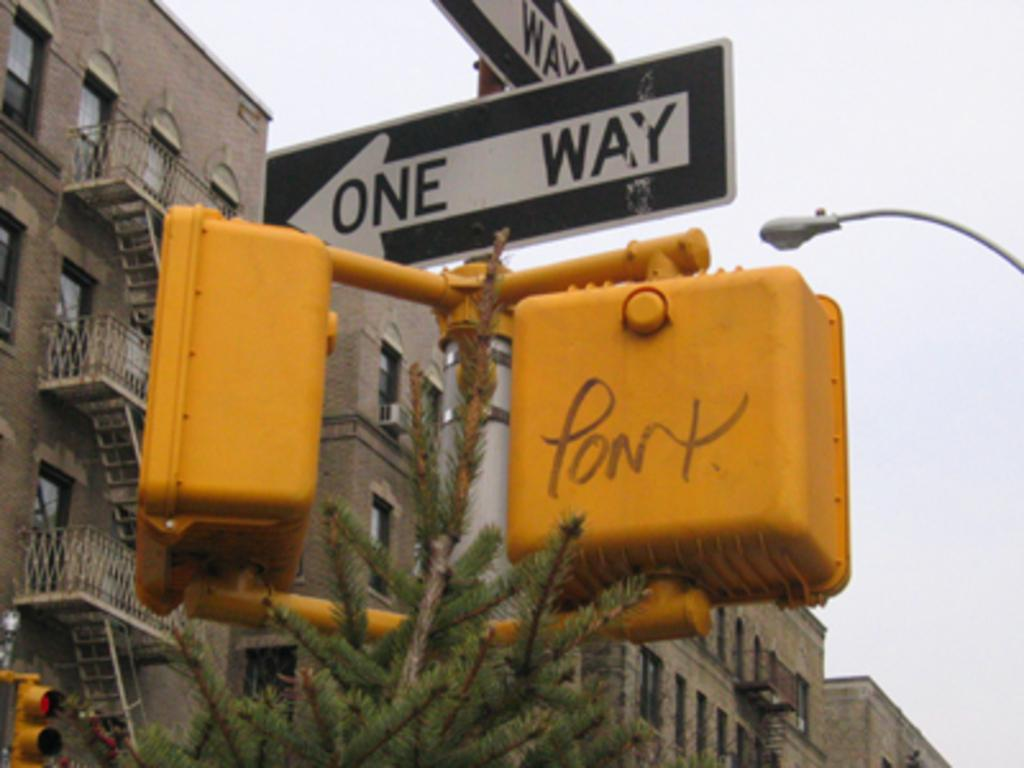<image>
Offer a succinct explanation of the picture presented. A sign that says one way with yellow walking lights 